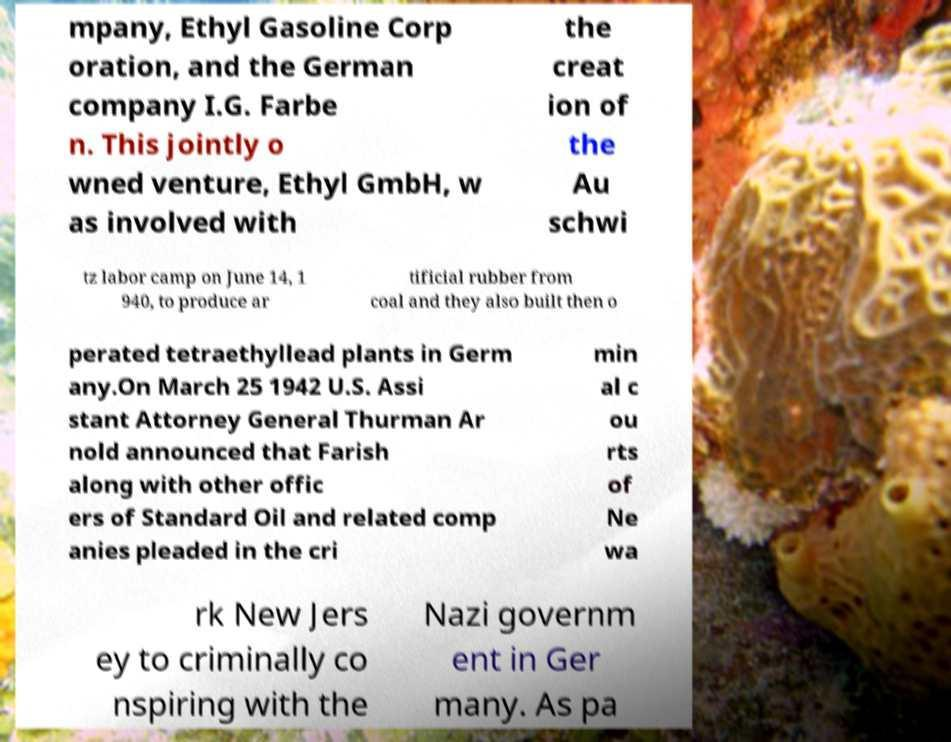Could you assist in decoding the text presented in this image and type it out clearly? mpany, Ethyl Gasoline Corp oration, and the German company I.G. Farbe n. This jointly o wned venture, Ethyl GmbH, w as involved with the creat ion of the Au schwi tz labor camp on June 14, 1 940, to produce ar tificial rubber from coal and they also built then o perated tetraethyllead plants in Germ any.On March 25 1942 U.S. Assi stant Attorney General Thurman Ar nold announced that Farish along with other offic ers of Standard Oil and related comp anies pleaded in the cri min al c ou rts of Ne wa rk New Jers ey to criminally co nspiring with the Nazi governm ent in Ger many. As pa 